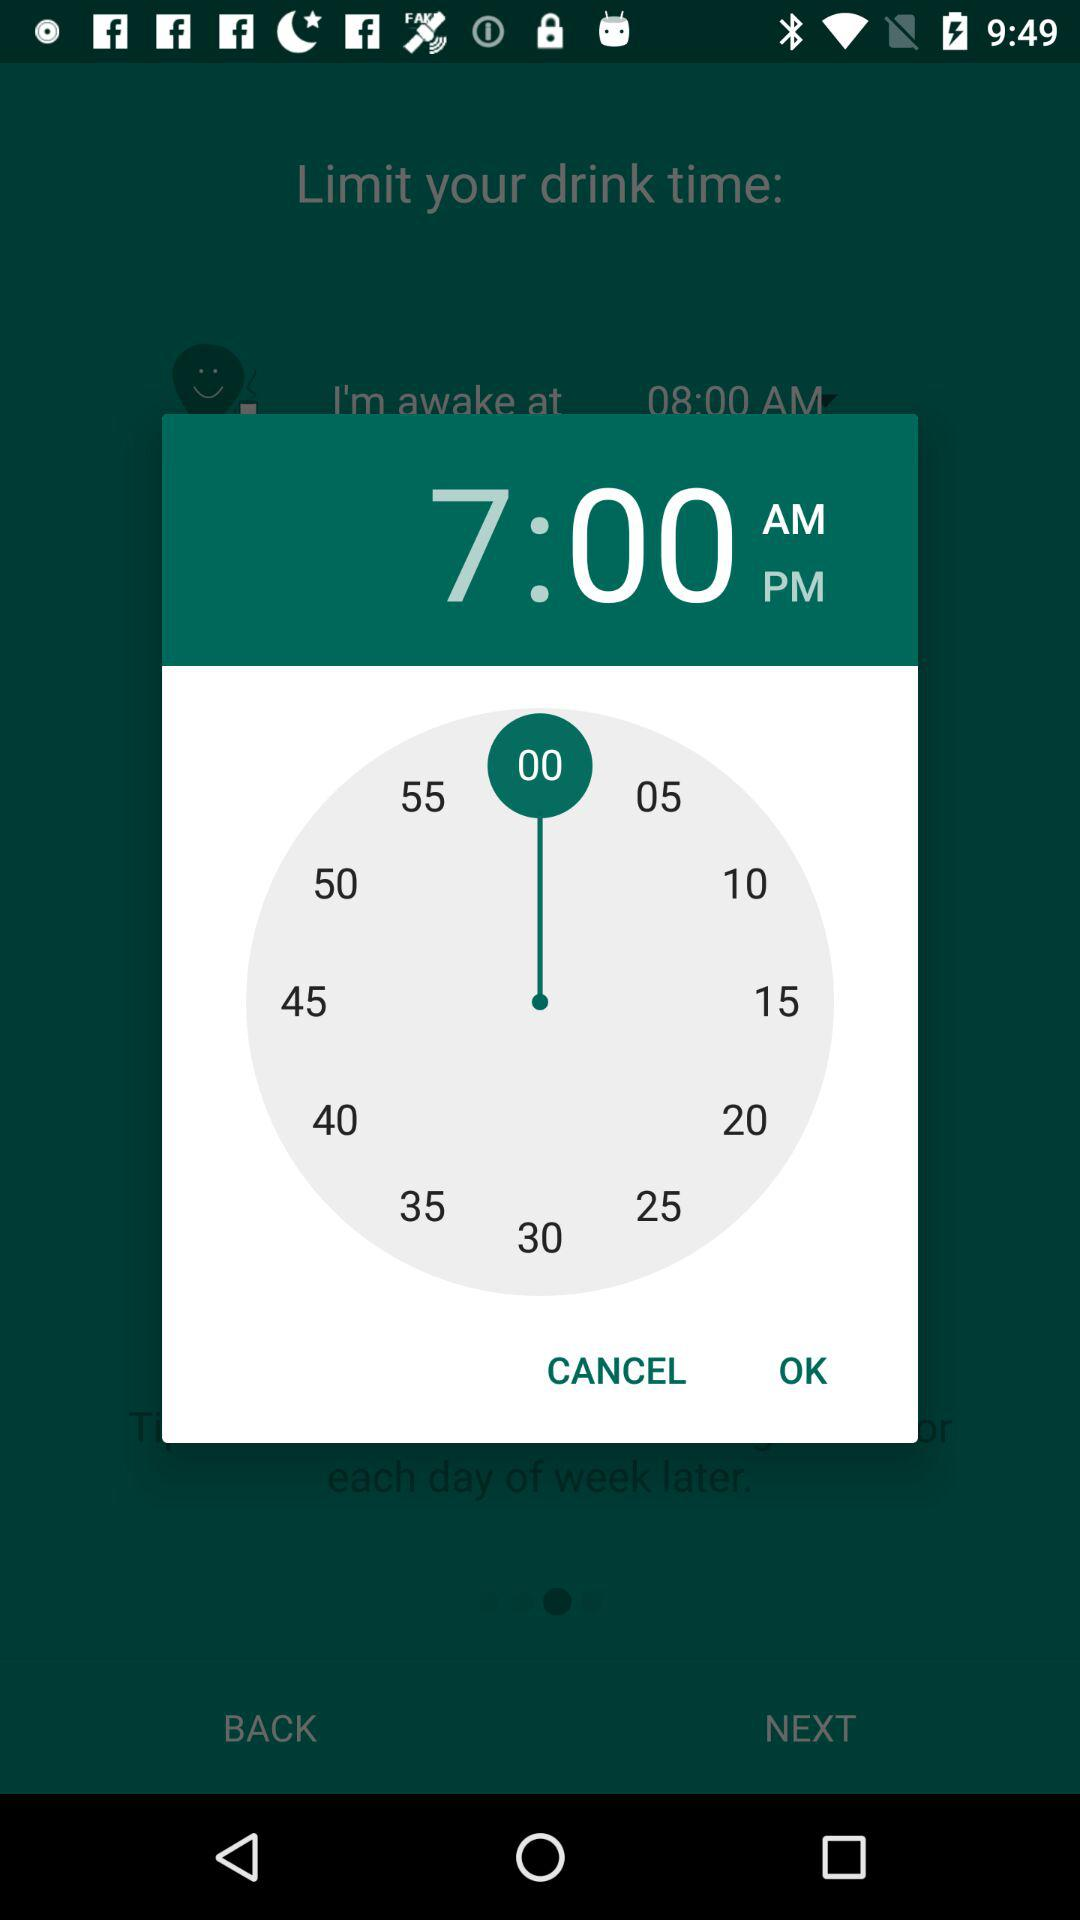How many more minutes are there between 7:00 and 7:15 than between 7:00 and 7:05?
Answer the question using a single word or phrase. 10 